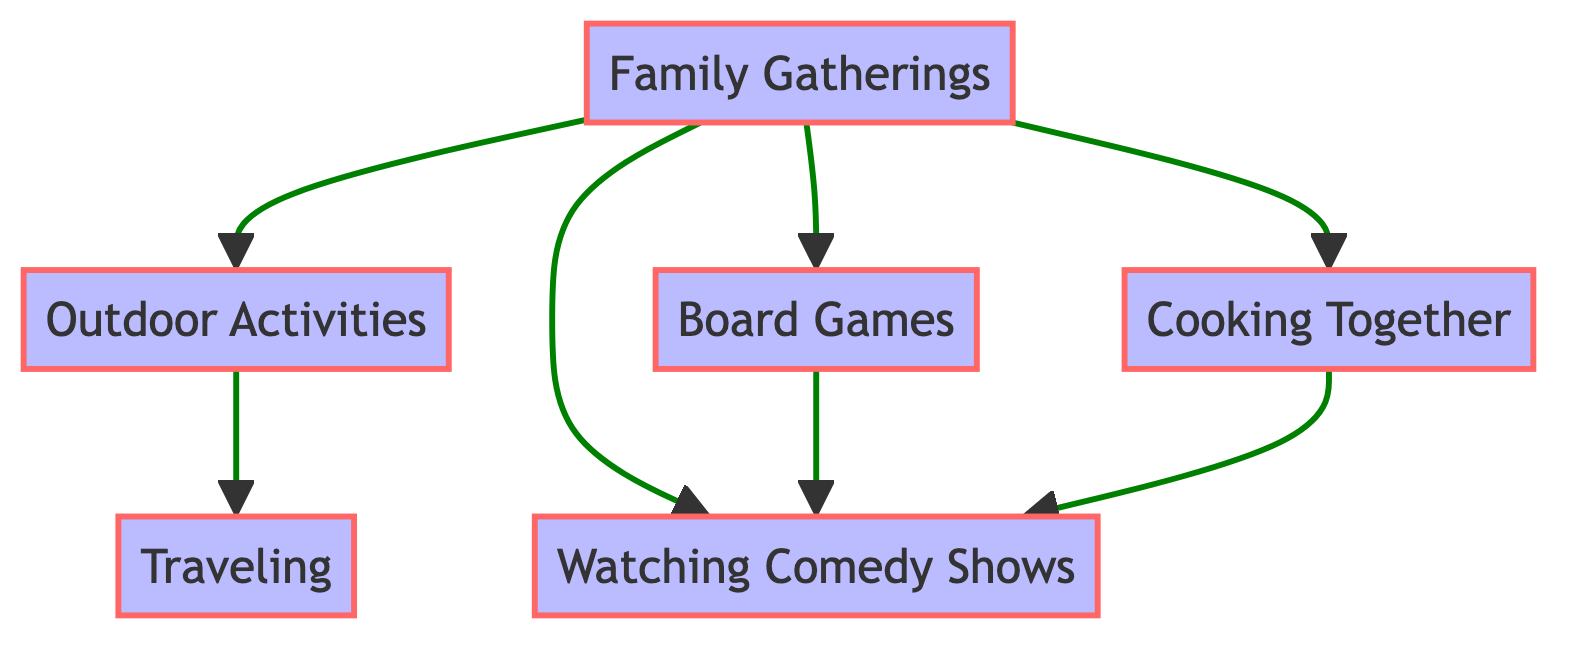What are the main activities represented in the diagram? The diagram includes nodes for Family Gatherings, Outdoor Activities, Board Games, Watching Comedy Shows, Cooking Together, and Traveling, which all represent different family activities.
Answer: Family Gatherings, Outdoor Activities, Board Games, Watching Comedy Shows, Cooking Together, Traveling How many nodes are there in the diagram? By counting each of the unique activities represented as nodes in the diagram, we find there are six nodes total: Family Gatherings, Outdoor Activities, Board Games, Watching Comedy Shows, Cooking Together, and Traveling.
Answer: 6 What is the relationship between Family Gatherings and Watching Comedy Shows? The directed edge from Family Gatherings to Watching Comedy Shows signifies that Family Gatherings influence or lead to Watching Comedy Shows, indicating a direct relationship.
Answer: Family Gatherings influences Watching Comedy Shows Which activity leads directly to Traveling? The edge leading from Outdoor Activities to Traveling indicates that Outdoor Activities is the activity that directly leads to Traveling.
Answer: Outdoor Activities How many activities are influenced by Family Gatherings? Observing the directed edges from Family Gatherings, there are four other activities (Outdoor Activities, Board Games, Watching Comedy Shows, Cooking Together) that are directly influenced.
Answer: 4 What activity is at the end of the longest path starting from Family Gatherings? Tracing the longest path starting from Family Gatherings, we go through Outdoor Activities to Traveling, making Traveling the endpoint of this path.
Answer: Traveling Which activities are connected by a direct relationship? By examining the edges of the diagram, we find that there are several direct relationships, including Family Gatherings to Outdoor Activities, Family Gatherings to Board Games, Family Gatherings to Watching Comedy Shows, Family Gatherings to Cooking Together, Outdoor Activities to Traveling, Board Games to Watching Comedy Shows, and Cooking Together to Watching Comedy Shows.
Answer: Family Gatherings to Outdoor Activities, Board Games, Watching Comedy Shows, Cooking Together; Outdoor Activities to Traveling; Board Games to Watching Comedy Shows; Cooking Together to Watching Comedy Shows What is the total number of directed edges in the diagram? Counting the directed edges, we find that there are a total of seven edges that represent direct relationships between the nodes in the diagram.
Answer: 7 Which activity connects both Cooking Together and Board Games? The directed edge pointing from Cooking Together and Board Games leading to Watching Comedy Shows indicates that both activities share this common connection to Watching Comedy Shows.
Answer: Watching Comedy Shows 